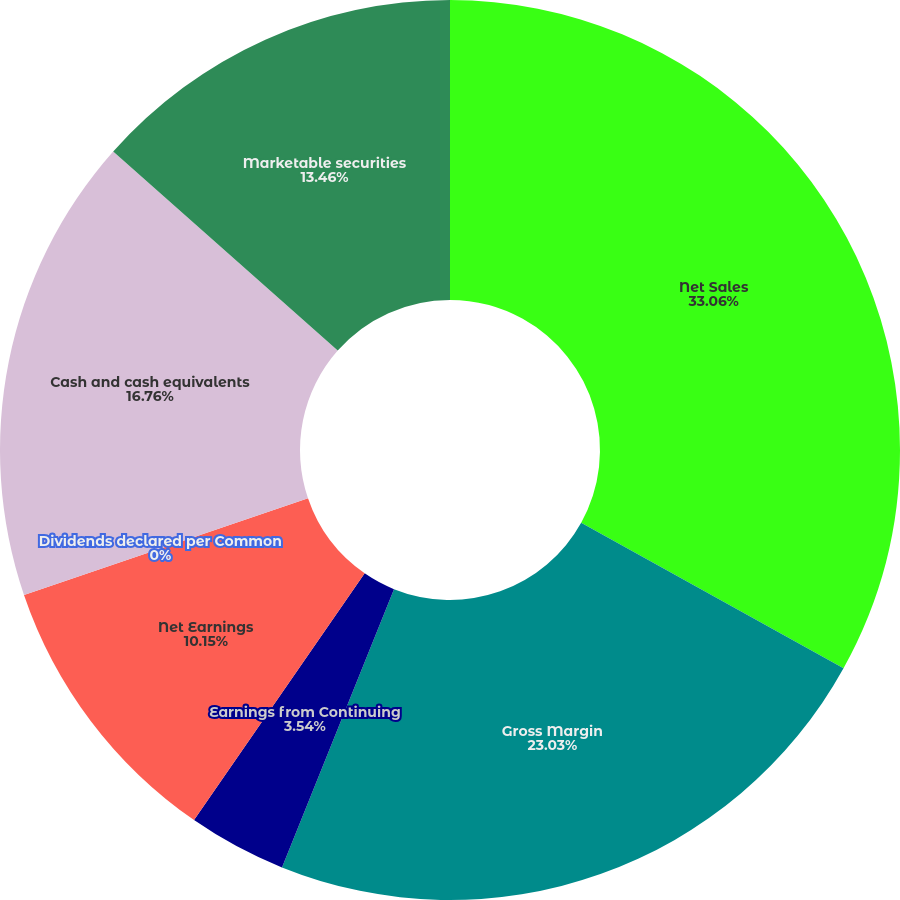Convert chart to OTSL. <chart><loc_0><loc_0><loc_500><loc_500><pie_chart><fcel>Net Sales<fcel>Gross Margin<fcel>Earnings from Continuing<fcel>Net Earnings<fcel>Dividends declared per Common<fcel>Cash and cash equivalents<fcel>Marketable securities<nl><fcel>33.06%<fcel>23.03%<fcel>3.54%<fcel>10.15%<fcel>0.0%<fcel>16.76%<fcel>13.46%<nl></chart> 